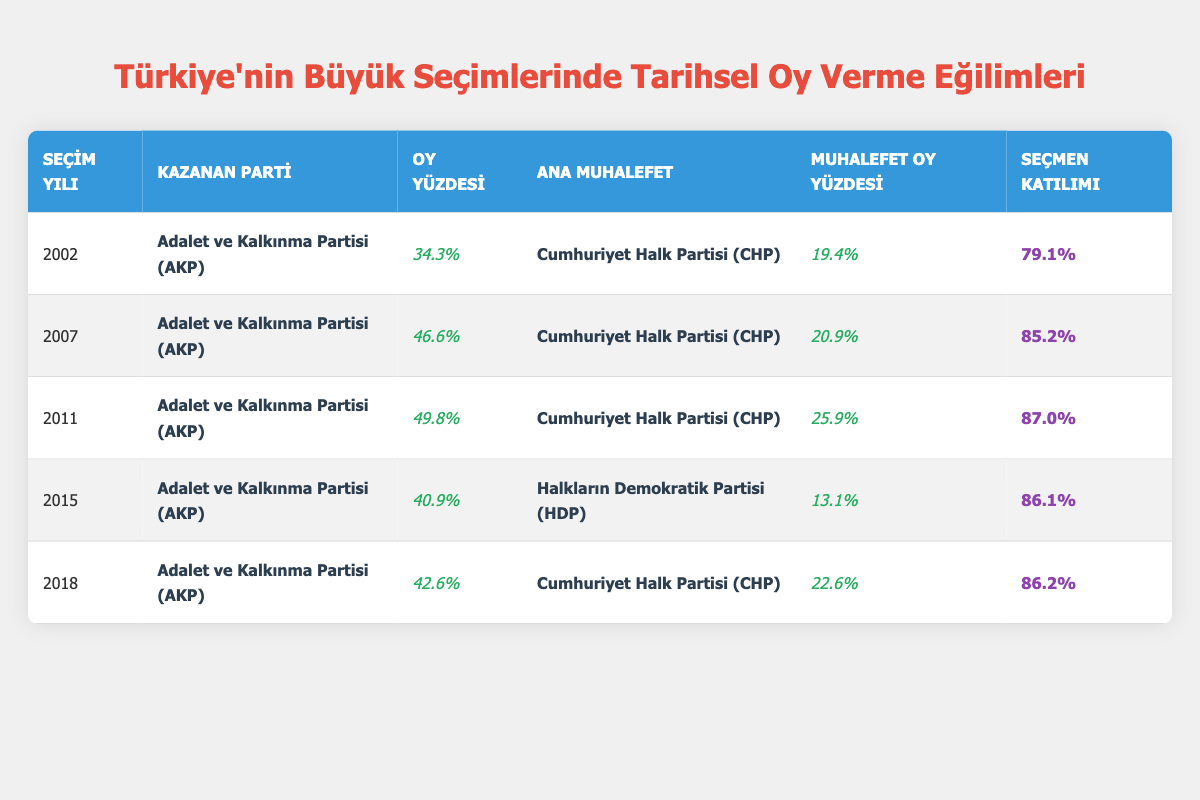What was the voter turnout in the 2011 election? According to the table, the voter turnout for the 2011 election is directly listed under the "Seçmen Katılımı" column. Looking at the row for the year 2011, the figure is 87.0%.
Answer: 87.0% Which party had the highest votes percentage in the 2007 election? In the table, the 2007 election row shows that the Justice and Development Party (AKP) obtained 46.6% of the votes, which is greater than the opponent's percentage of 20.9%. Therefore, AKP had the highest votes percentage in that election.
Answer: Justice and Development Party (AKP) What is the difference in votes percentage between AKP and CHP in the 2018 election? For the 2018 election, the Justice and Development Party (AKP) received 42.6% of the votes, while the Republican People's Party (CHP) received 22.6%. The difference is calculated as 42.6% - 22.6%, which equals 20%.
Answer: 20% Was the voter turnout higher in 2002 or 2015? To answer this question, we refer to the "Seçmen Katılımı" column. The voter turnout in 2002 was 79.1%, and in 2015 it was 86.1%. Since 86.1% is greater than 79.1%, it can be concluded that the voter turnout was higher in 2015.
Answer: Yes What was the average votes percentage of AKP from 2002 to 2018? We need to first gather the votes percentages of AKP from each relevant year: 34.3% (2002), 46.6% (2007), 49.8% (2011), 40.9% (2015), and 42.6% (2018). We sum these values: 34.3 + 46.6 + 49.8 + 40.9 + 42.6 = 214.2%. To find the average, we divide this sum by the number of elections (5), giving us 214.2% / 5 = 42.84%.
Answer: 42.84% In which year did AKP's votes percentage drop compared to the previous election? By examining the table, we see that AKP's percentage dropped from 49.8% in 2011 to 40.9% in 2015, showing a decrease. Thus, 2015 is the year when AKP's votes percentage dropped compared to 2011.
Answer: 2015 